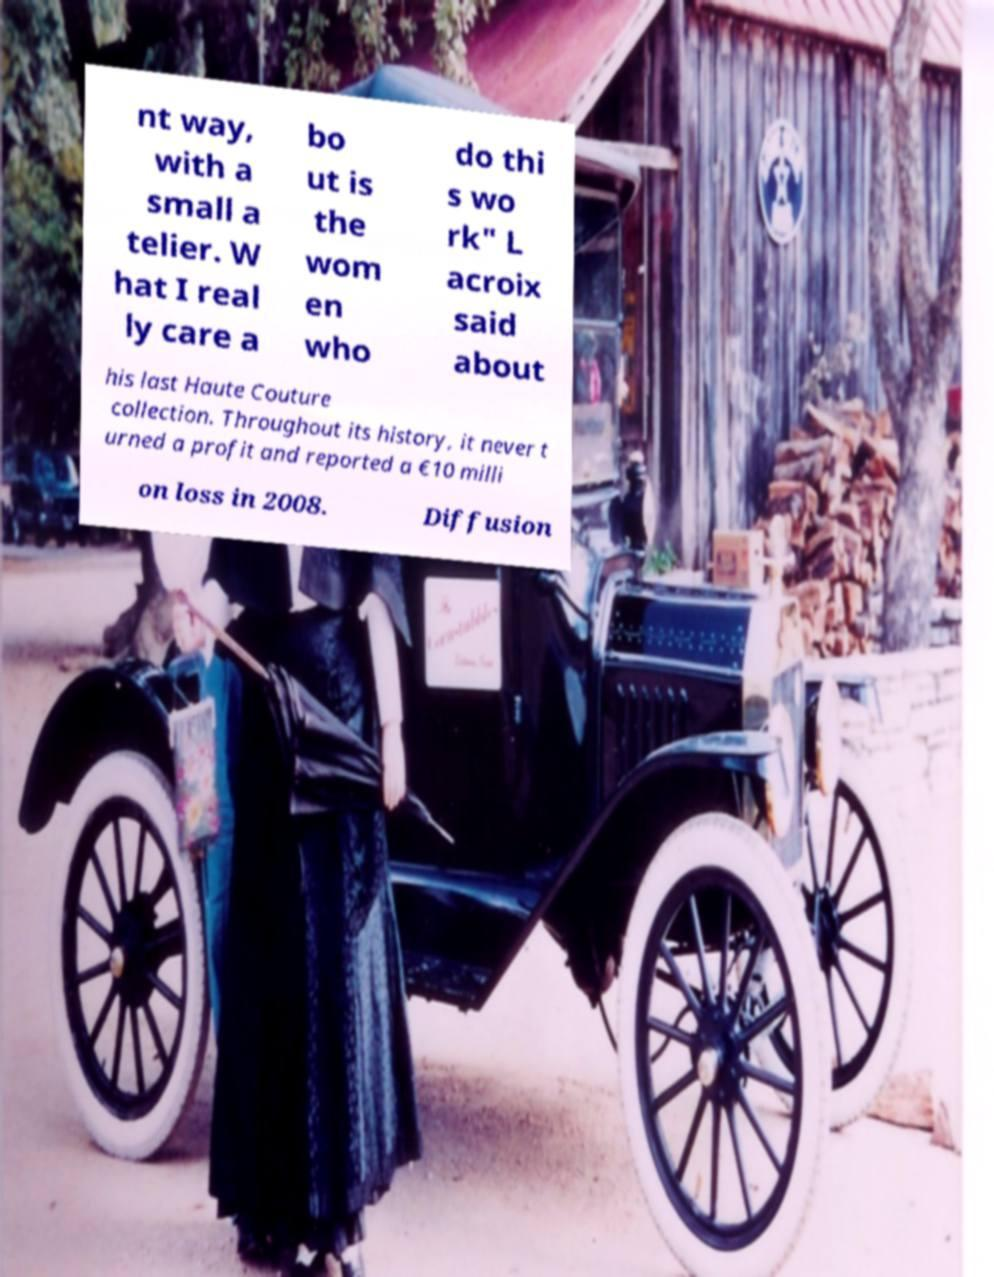There's text embedded in this image that I need extracted. Can you transcribe it verbatim? nt way, with a small a telier. W hat I real ly care a bo ut is the wom en who do thi s wo rk" L acroix said about his last Haute Couture collection. Throughout its history, it never t urned a profit and reported a €10 milli on loss in 2008. Diffusion 